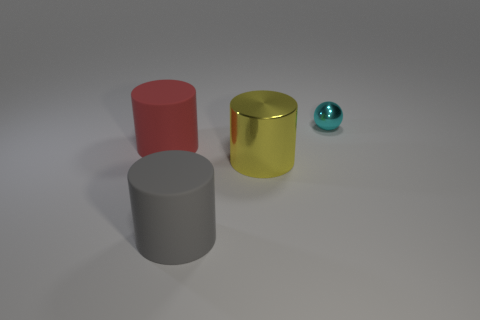Are there any other things that have the same size as the cyan sphere?
Provide a short and direct response. No. There is a small cyan sphere that is right of the metal thing that is in front of the tiny shiny sphere; how many big yellow cylinders are in front of it?
Keep it short and to the point. 1. Are there any other things that are the same color as the tiny sphere?
Make the answer very short. No. What number of things are in front of the tiny cyan thing and behind the red thing?
Make the answer very short. 0. Does the shiny object left of the small metal ball have the same size as the metallic object behind the large red matte object?
Provide a short and direct response. No. What number of objects are large rubber cylinders right of the red cylinder or large red matte objects?
Offer a terse response. 2. What is the small sphere that is to the right of the large metallic thing made of?
Ensure brevity in your answer.  Metal. What is the large yellow cylinder made of?
Your answer should be very brief. Metal. What material is the thing that is behind the big matte thing left of the matte cylinder in front of the red rubber cylinder?
Provide a succinct answer. Metal. Is there anything else that has the same material as the big gray thing?
Offer a terse response. Yes. 